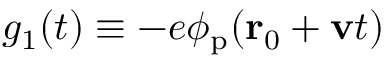<formula> <loc_0><loc_0><loc_500><loc_500>g _ { 1 } ( t ) \equiv - e \phi _ { p } ( r _ { 0 } + v t )</formula> 